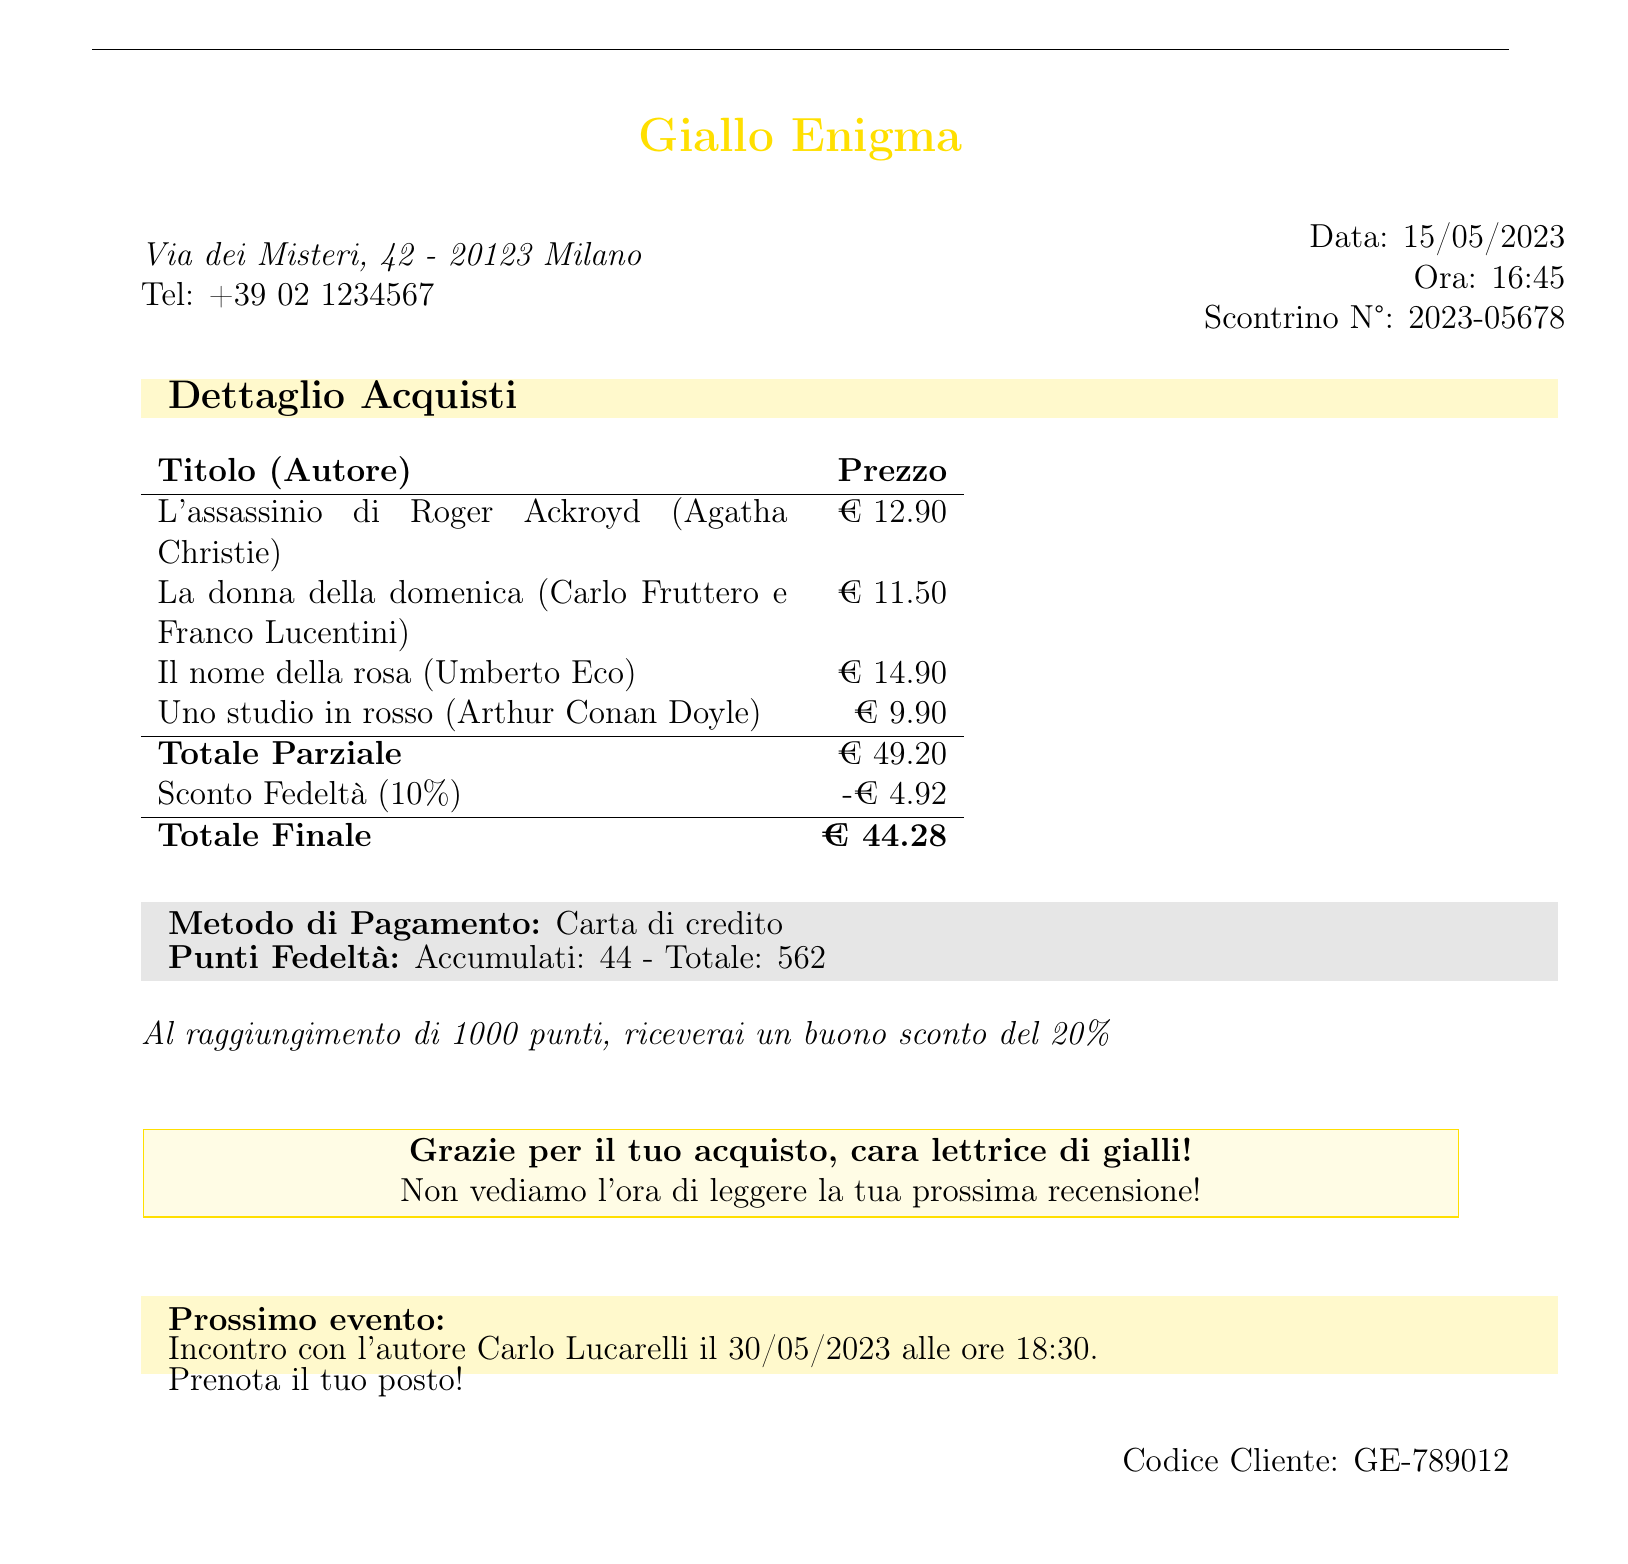what is the name of the bookstore? The name of the bookstore is found at the top of the document.
Answer: Giallo Enigma what is the date of the receipt? The date of the receipt indicates when the transaction occurred and can be found next to "Data".
Answer: 15/05/2023 how many loyalty points were accumulated? The number of loyalty points accumulated is listed in the section detailing loyalty points.
Answer: 44 what is the total final amount after discount? The total final amount is calculated after applying the discount and is specified towards the end of the purchase details.
Answer: € 44.28 who is the author of "Il nome della rosa"? The author of the book can be found in the detailed list of purchases.
Answer: Umberto Eco what percentage is the loyalty discount? The percentage of the loyalty discount is specified in the discount section of the receipt.
Answer: 10% when is the next author event? The date of the next author event is explicitly listed towards the bottom of the document.
Answer: 30/05/2023 what payment method was used? The payment method is stated in the payment details section.
Answer: Carta di credito what is the discount amount applied? The discount amount is indicated in the summary section where discounts are listed.
Answer: -€ 4.92 